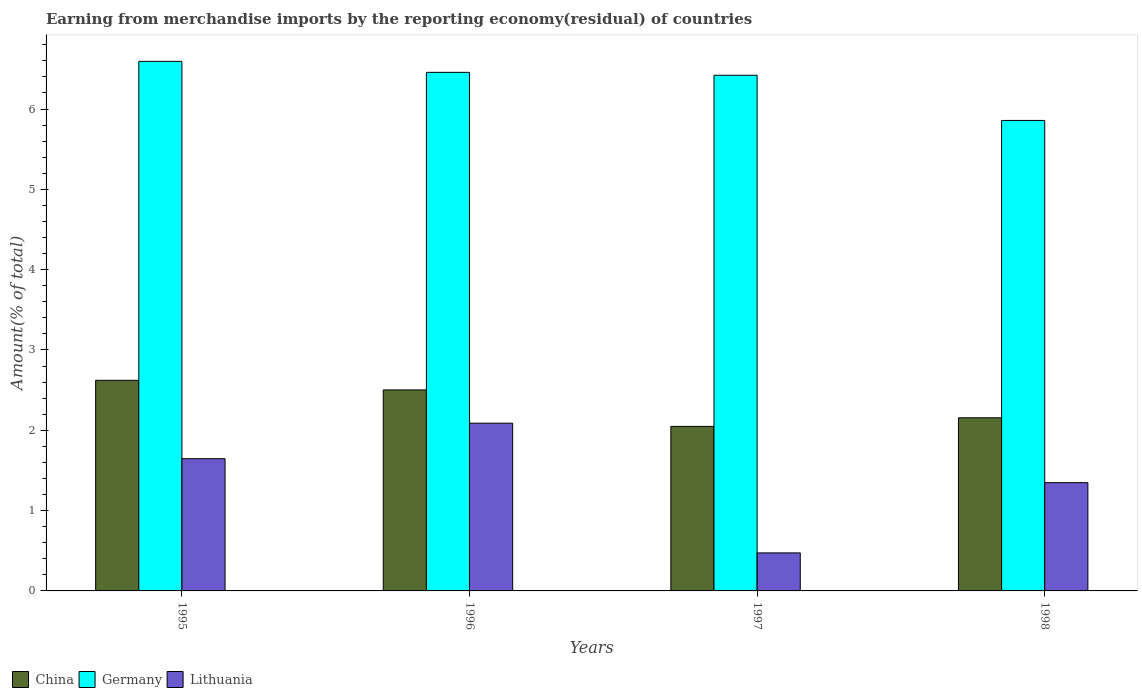How many different coloured bars are there?
Keep it short and to the point. 3. How many bars are there on the 2nd tick from the left?
Offer a terse response. 3. What is the label of the 2nd group of bars from the left?
Make the answer very short. 1996. In how many cases, is the number of bars for a given year not equal to the number of legend labels?
Your answer should be very brief. 0. What is the percentage of amount earned from merchandise imports in Germany in 1995?
Provide a short and direct response. 6.59. Across all years, what is the maximum percentage of amount earned from merchandise imports in Lithuania?
Make the answer very short. 2.09. Across all years, what is the minimum percentage of amount earned from merchandise imports in Lithuania?
Your answer should be very brief. 0.47. What is the total percentage of amount earned from merchandise imports in China in the graph?
Your answer should be very brief. 9.33. What is the difference between the percentage of amount earned from merchandise imports in China in 1997 and that in 1998?
Ensure brevity in your answer.  -0.11. What is the difference between the percentage of amount earned from merchandise imports in Germany in 1996 and the percentage of amount earned from merchandise imports in China in 1995?
Give a very brief answer. 3.83. What is the average percentage of amount earned from merchandise imports in China per year?
Provide a short and direct response. 2.33. In the year 1995, what is the difference between the percentage of amount earned from merchandise imports in Germany and percentage of amount earned from merchandise imports in China?
Make the answer very short. 3.97. What is the ratio of the percentage of amount earned from merchandise imports in China in 1995 to that in 1997?
Your answer should be compact. 1.28. Is the percentage of amount earned from merchandise imports in China in 1995 less than that in 1997?
Provide a short and direct response. No. Is the difference between the percentage of amount earned from merchandise imports in Germany in 1996 and 1997 greater than the difference between the percentage of amount earned from merchandise imports in China in 1996 and 1997?
Offer a very short reply. No. What is the difference between the highest and the second highest percentage of amount earned from merchandise imports in Germany?
Your answer should be compact. 0.14. What is the difference between the highest and the lowest percentage of amount earned from merchandise imports in China?
Make the answer very short. 0.57. Is the sum of the percentage of amount earned from merchandise imports in Lithuania in 1995 and 1996 greater than the maximum percentage of amount earned from merchandise imports in Germany across all years?
Make the answer very short. No. What does the 3rd bar from the left in 1998 represents?
Offer a terse response. Lithuania. How many bars are there?
Give a very brief answer. 12. Are all the bars in the graph horizontal?
Provide a short and direct response. No. Does the graph contain any zero values?
Offer a terse response. No. How many legend labels are there?
Your answer should be very brief. 3. What is the title of the graph?
Give a very brief answer. Earning from merchandise imports by the reporting economy(residual) of countries. What is the label or title of the X-axis?
Keep it short and to the point. Years. What is the label or title of the Y-axis?
Your response must be concise. Amount(% of total). What is the Amount(% of total) in China in 1995?
Offer a very short reply. 2.62. What is the Amount(% of total) in Germany in 1995?
Your answer should be compact. 6.59. What is the Amount(% of total) in Lithuania in 1995?
Keep it short and to the point. 1.65. What is the Amount(% of total) of China in 1996?
Keep it short and to the point. 2.5. What is the Amount(% of total) in Germany in 1996?
Your answer should be compact. 6.46. What is the Amount(% of total) in Lithuania in 1996?
Your response must be concise. 2.09. What is the Amount(% of total) in China in 1997?
Ensure brevity in your answer.  2.05. What is the Amount(% of total) in Germany in 1997?
Offer a terse response. 6.42. What is the Amount(% of total) of Lithuania in 1997?
Offer a very short reply. 0.47. What is the Amount(% of total) in China in 1998?
Your answer should be very brief. 2.16. What is the Amount(% of total) in Germany in 1998?
Keep it short and to the point. 5.86. What is the Amount(% of total) of Lithuania in 1998?
Your answer should be compact. 1.35. Across all years, what is the maximum Amount(% of total) in China?
Offer a terse response. 2.62. Across all years, what is the maximum Amount(% of total) in Germany?
Make the answer very short. 6.59. Across all years, what is the maximum Amount(% of total) in Lithuania?
Ensure brevity in your answer.  2.09. Across all years, what is the minimum Amount(% of total) in China?
Offer a very short reply. 2.05. Across all years, what is the minimum Amount(% of total) in Germany?
Make the answer very short. 5.86. Across all years, what is the minimum Amount(% of total) in Lithuania?
Offer a very short reply. 0.47. What is the total Amount(% of total) in China in the graph?
Offer a terse response. 9.33. What is the total Amount(% of total) in Germany in the graph?
Give a very brief answer. 25.33. What is the total Amount(% of total) of Lithuania in the graph?
Provide a short and direct response. 5.56. What is the difference between the Amount(% of total) of China in 1995 and that in 1996?
Offer a terse response. 0.12. What is the difference between the Amount(% of total) of Germany in 1995 and that in 1996?
Provide a short and direct response. 0.14. What is the difference between the Amount(% of total) in Lithuania in 1995 and that in 1996?
Provide a short and direct response. -0.44. What is the difference between the Amount(% of total) of China in 1995 and that in 1997?
Provide a succinct answer. 0.57. What is the difference between the Amount(% of total) in Germany in 1995 and that in 1997?
Your answer should be compact. 0.17. What is the difference between the Amount(% of total) of Lithuania in 1995 and that in 1997?
Your answer should be very brief. 1.17. What is the difference between the Amount(% of total) of China in 1995 and that in 1998?
Your response must be concise. 0.47. What is the difference between the Amount(% of total) of Germany in 1995 and that in 1998?
Your response must be concise. 0.74. What is the difference between the Amount(% of total) of Lithuania in 1995 and that in 1998?
Make the answer very short. 0.3. What is the difference between the Amount(% of total) of China in 1996 and that in 1997?
Provide a short and direct response. 0.45. What is the difference between the Amount(% of total) in Germany in 1996 and that in 1997?
Ensure brevity in your answer.  0.04. What is the difference between the Amount(% of total) of Lithuania in 1996 and that in 1997?
Provide a succinct answer. 1.62. What is the difference between the Amount(% of total) of China in 1996 and that in 1998?
Offer a terse response. 0.35. What is the difference between the Amount(% of total) in Germany in 1996 and that in 1998?
Your response must be concise. 0.6. What is the difference between the Amount(% of total) of Lithuania in 1996 and that in 1998?
Ensure brevity in your answer.  0.74. What is the difference between the Amount(% of total) in China in 1997 and that in 1998?
Make the answer very short. -0.11. What is the difference between the Amount(% of total) in Germany in 1997 and that in 1998?
Ensure brevity in your answer.  0.56. What is the difference between the Amount(% of total) of Lithuania in 1997 and that in 1998?
Provide a short and direct response. -0.87. What is the difference between the Amount(% of total) of China in 1995 and the Amount(% of total) of Germany in 1996?
Offer a terse response. -3.83. What is the difference between the Amount(% of total) in China in 1995 and the Amount(% of total) in Lithuania in 1996?
Your answer should be compact. 0.53. What is the difference between the Amount(% of total) of Germany in 1995 and the Amount(% of total) of Lithuania in 1996?
Make the answer very short. 4.51. What is the difference between the Amount(% of total) of China in 1995 and the Amount(% of total) of Germany in 1997?
Make the answer very short. -3.8. What is the difference between the Amount(% of total) of China in 1995 and the Amount(% of total) of Lithuania in 1997?
Provide a succinct answer. 2.15. What is the difference between the Amount(% of total) in Germany in 1995 and the Amount(% of total) in Lithuania in 1997?
Ensure brevity in your answer.  6.12. What is the difference between the Amount(% of total) of China in 1995 and the Amount(% of total) of Germany in 1998?
Your answer should be compact. -3.24. What is the difference between the Amount(% of total) in China in 1995 and the Amount(% of total) in Lithuania in 1998?
Give a very brief answer. 1.27. What is the difference between the Amount(% of total) of Germany in 1995 and the Amount(% of total) of Lithuania in 1998?
Give a very brief answer. 5.25. What is the difference between the Amount(% of total) of China in 1996 and the Amount(% of total) of Germany in 1997?
Give a very brief answer. -3.92. What is the difference between the Amount(% of total) in China in 1996 and the Amount(% of total) in Lithuania in 1997?
Your answer should be compact. 2.03. What is the difference between the Amount(% of total) in Germany in 1996 and the Amount(% of total) in Lithuania in 1997?
Your response must be concise. 5.98. What is the difference between the Amount(% of total) of China in 1996 and the Amount(% of total) of Germany in 1998?
Your response must be concise. -3.36. What is the difference between the Amount(% of total) of China in 1996 and the Amount(% of total) of Lithuania in 1998?
Offer a very short reply. 1.15. What is the difference between the Amount(% of total) in Germany in 1996 and the Amount(% of total) in Lithuania in 1998?
Ensure brevity in your answer.  5.11. What is the difference between the Amount(% of total) in China in 1997 and the Amount(% of total) in Germany in 1998?
Offer a very short reply. -3.81. What is the difference between the Amount(% of total) in China in 1997 and the Amount(% of total) in Lithuania in 1998?
Your answer should be very brief. 0.7. What is the difference between the Amount(% of total) of Germany in 1997 and the Amount(% of total) of Lithuania in 1998?
Provide a short and direct response. 5.07. What is the average Amount(% of total) of China per year?
Keep it short and to the point. 2.33. What is the average Amount(% of total) of Germany per year?
Your response must be concise. 6.33. What is the average Amount(% of total) of Lithuania per year?
Ensure brevity in your answer.  1.39. In the year 1995, what is the difference between the Amount(% of total) in China and Amount(% of total) in Germany?
Your answer should be very brief. -3.97. In the year 1995, what is the difference between the Amount(% of total) in China and Amount(% of total) in Lithuania?
Keep it short and to the point. 0.98. In the year 1995, what is the difference between the Amount(% of total) of Germany and Amount(% of total) of Lithuania?
Give a very brief answer. 4.95. In the year 1996, what is the difference between the Amount(% of total) in China and Amount(% of total) in Germany?
Your response must be concise. -3.95. In the year 1996, what is the difference between the Amount(% of total) in China and Amount(% of total) in Lithuania?
Keep it short and to the point. 0.41. In the year 1996, what is the difference between the Amount(% of total) of Germany and Amount(% of total) of Lithuania?
Ensure brevity in your answer.  4.37. In the year 1997, what is the difference between the Amount(% of total) in China and Amount(% of total) in Germany?
Your answer should be compact. -4.37. In the year 1997, what is the difference between the Amount(% of total) of China and Amount(% of total) of Lithuania?
Provide a short and direct response. 1.58. In the year 1997, what is the difference between the Amount(% of total) of Germany and Amount(% of total) of Lithuania?
Your response must be concise. 5.95. In the year 1998, what is the difference between the Amount(% of total) in China and Amount(% of total) in Germany?
Keep it short and to the point. -3.7. In the year 1998, what is the difference between the Amount(% of total) of China and Amount(% of total) of Lithuania?
Your response must be concise. 0.81. In the year 1998, what is the difference between the Amount(% of total) in Germany and Amount(% of total) in Lithuania?
Offer a very short reply. 4.51. What is the ratio of the Amount(% of total) in China in 1995 to that in 1996?
Give a very brief answer. 1.05. What is the ratio of the Amount(% of total) in Germany in 1995 to that in 1996?
Ensure brevity in your answer.  1.02. What is the ratio of the Amount(% of total) of Lithuania in 1995 to that in 1996?
Your answer should be compact. 0.79. What is the ratio of the Amount(% of total) of China in 1995 to that in 1997?
Your response must be concise. 1.28. What is the ratio of the Amount(% of total) of Germany in 1995 to that in 1997?
Give a very brief answer. 1.03. What is the ratio of the Amount(% of total) in Lithuania in 1995 to that in 1997?
Make the answer very short. 3.48. What is the ratio of the Amount(% of total) of China in 1995 to that in 1998?
Your response must be concise. 1.22. What is the ratio of the Amount(% of total) of Germany in 1995 to that in 1998?
Offer a terse response. 1.13. What is the ratio of the Amount(% of total) of Lithuania in 1995 to that in 1998?
Ensure brevity in your answer.  1.22. What is the ratio of the Amount(% of total) in China in 1996 to that in 1997?
Your answer should be compact. 1.22. What is the ratio of the Amount(% of total) of Germany in 1996 to that in 1997?
Offer a terse response. 1.01. What is the ratio of the Amount(% of total) in Lithuania in 1996 to that in 1997?
Your response must be concise. 4.41. What is the ratio of the Amount(% of total) in China in 1996 to that in 1998?
Your response must be concise. 1.16. What is the ratio of the Amount(% of total) of Germany in 1996 to that in 1998?
Give a very brief answer. 1.1. What is the ratio of the Amount(% of total) in Lithuania in 1996 to that in 1998?
Ensure brevity in your answer.  1.55. What is the ratio of the Amount(% of total) in China in 1997 to that in 1998?
Your answer should be compact. 0.95. What is the ratio of the Amount(% of total) in Germany in 1997 to that in 1998?
Provide a short and direct response. 1.1. What is the ratio of the Amount(% of total) in Lithuania in 1997 to that in 1998?
Make the answer very short. 0.35. What is the difference between the highest and the second highest Amount(% of total) of China?
Your answer should be compact. 0.12. What is the difference between the highest and the second highest Amount(% of total) in Germany?
Provide a succinct answer. 0.14. What is the difference between the highest and the second highest Amount(% of total) in Lithuania?
Give a very brief answer. 0.44. What is the difference between the highest and the lowest Amount(% of total) of China?
Give a very brief answer. 0.57. What is the difference between the highest and the lowest Amount(% of total) of Germany?
Provide a succinct answer. 0.74. What is the difference between the highest and the lowest Amount(% of total) of Lithuania?
Make the answer very short. 1.62. 